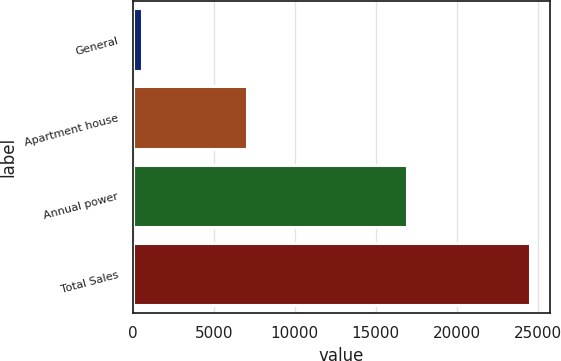<chart> <loc_0><loc_0><loc_500><loc_500><bar_chart><fcel>General<fcel>Apartment house<fcel>Annual power<fcel>Total Sales<nl><fcel>600<fcel>7022<fcel>16897<fcel>24519<nl></chart> 